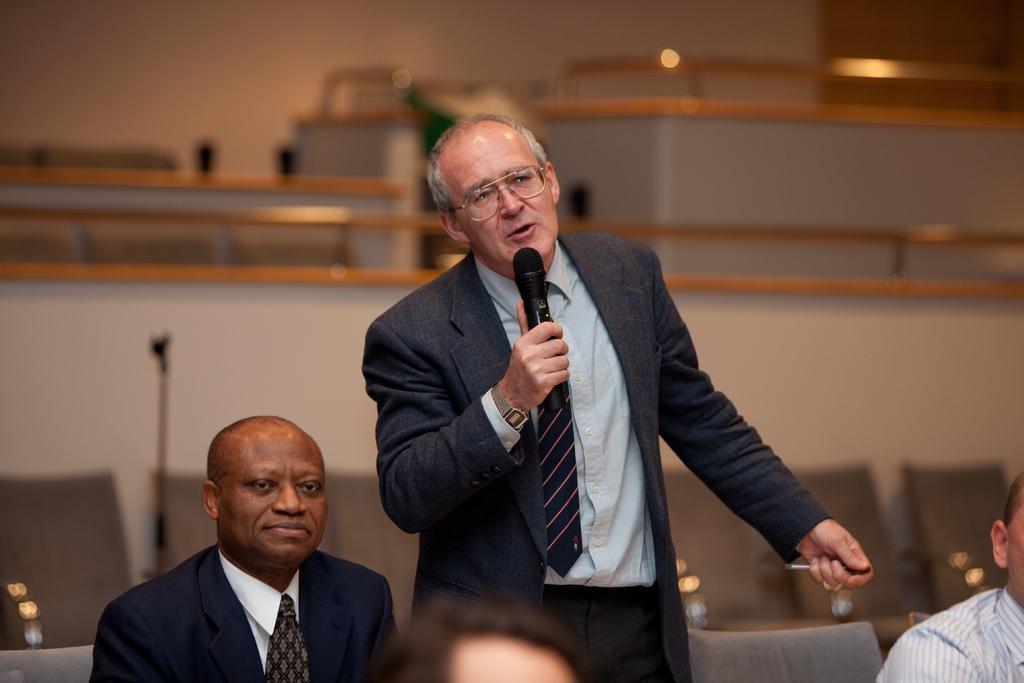How would you summarize this image in a sentence or two? The person wearing blue suit is standing and speaking in front of a mike and there are also few other persons sitting beside him. 